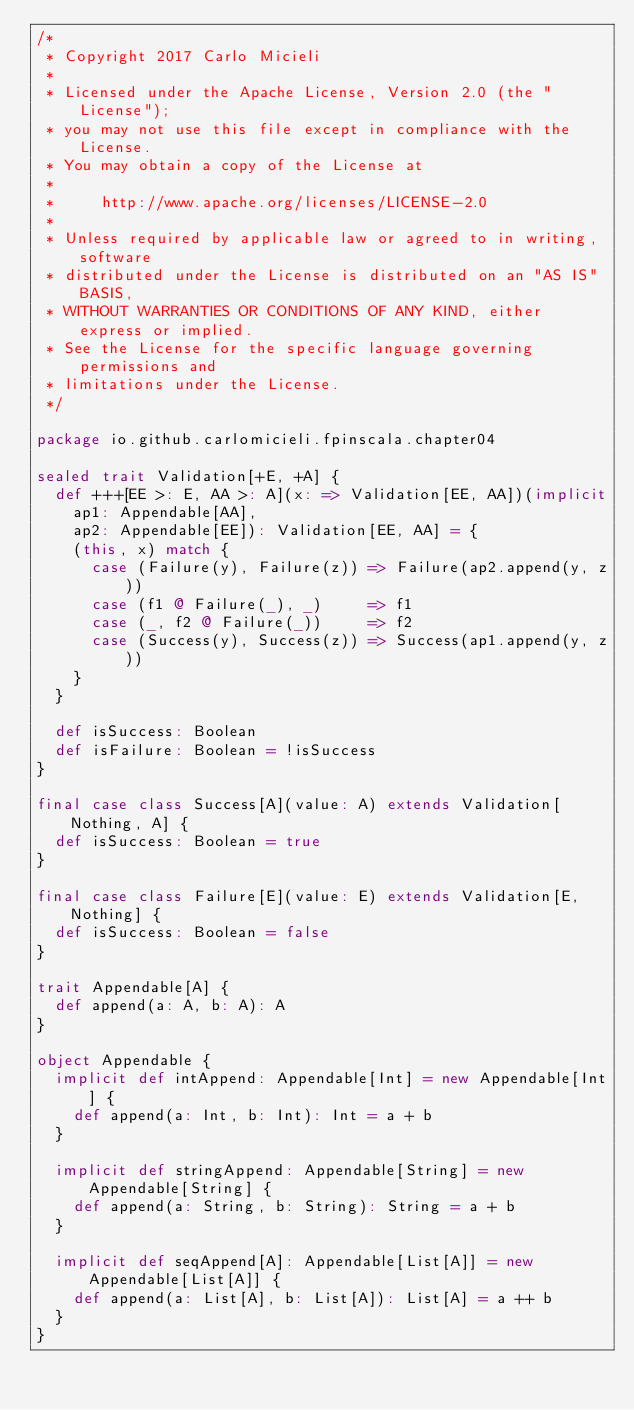<code> <loc_0><loc_0><loc_500><loc_500><_Scala_>/*
 * Copyright 2017 Carlo Micieli
 *
 * Licensed under the Apache License, Version 2.0 (the "License");
 * you may not use this file except in compliance with the License.
 * You may obtain a copy of the License at
 *
 *     http://www.apache.org/licenses/LICENSE-2.0
 *
 * Unless required by applicable law or agreed to in writing, software
 * distributed under the License is distributed on an "AS IS" BASIS,
 * WITHOUT WARRANTIES OR CONDITIONS OF ANY KIND, either express or implied.
 * See the License for the specific language governing permissions and
 * limitations under the License.
 */

package io.github.carlomicieli.fpinscala.chapter04

sealed trait Validation[+E, +A] {
  def +++[EE >: E, AA >: A](x: => Validation[EE, AA])(implicit
    ap1: Appendable[AA],
    ap2: Appendable[EE]): Validation[EE, AA] = {
    (this, x) match {
      case (Failure(y), Failure(z)) => Failure(ap2.append(y, z))
      case (f1 @ Failure(_), _)     => f1
      case (_, f2 @ Failure(_))     => f2
      case (Success(y), Success(z)) => Success(ap1.append(y, z))
    }
  }

  def isSuccess: Boolean
  def isFailure: Boolean = !isSuccess
}

final case class Success[A](value: A) extends Validation[Nothing, A] {
  def isSuccess: Boolean = true
}

final case class Failure[E](value: E) extends Validation[E, Nothing] {
  def isSuccess: Boolean = false
}

trait Appendable[A] {
  def append(a: A, b: A): A
}

object Appendable {
  implicit def intAppend: Appendable[Int] = new Appendable[Int] {
    def append(a: Int, b: Int): Int = a + b
  }

  implicit def stringAppend: Appendable[String] = new Appendable[String] {
    def append(a: String, b: String): String = a + b
  }

  implicit def seqAppend[A]: Appendable[List[A]] = new Appendable[List[A]] {
    def append(a: List[A], b: List[A]): List[A] = a ++ b
  }
}
</code> 